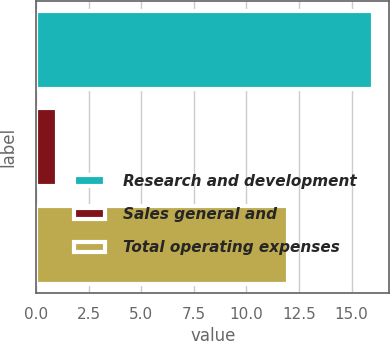Convert chart to OTSL. <chart><loc_0><loc_0><loc_500><loc_500><bar_chart><fcel>Research and development<fcel>Sales general and<fcel>Total operating expenses<nl><fcel>16<fcel>1<fcel>12<nl></chart> 